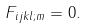Convert formula to latex. <formula><loc_0><loc_0><loc_500><loc_500>F _ { i j k l ; m } = 0 .</formula> 